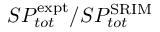<formula> <loc_0><loc_0><loc_500><loc_500>S P _ { t o t } ^ { e x p t } / S P _ { t o t } ^ { S R I M }</formula> 